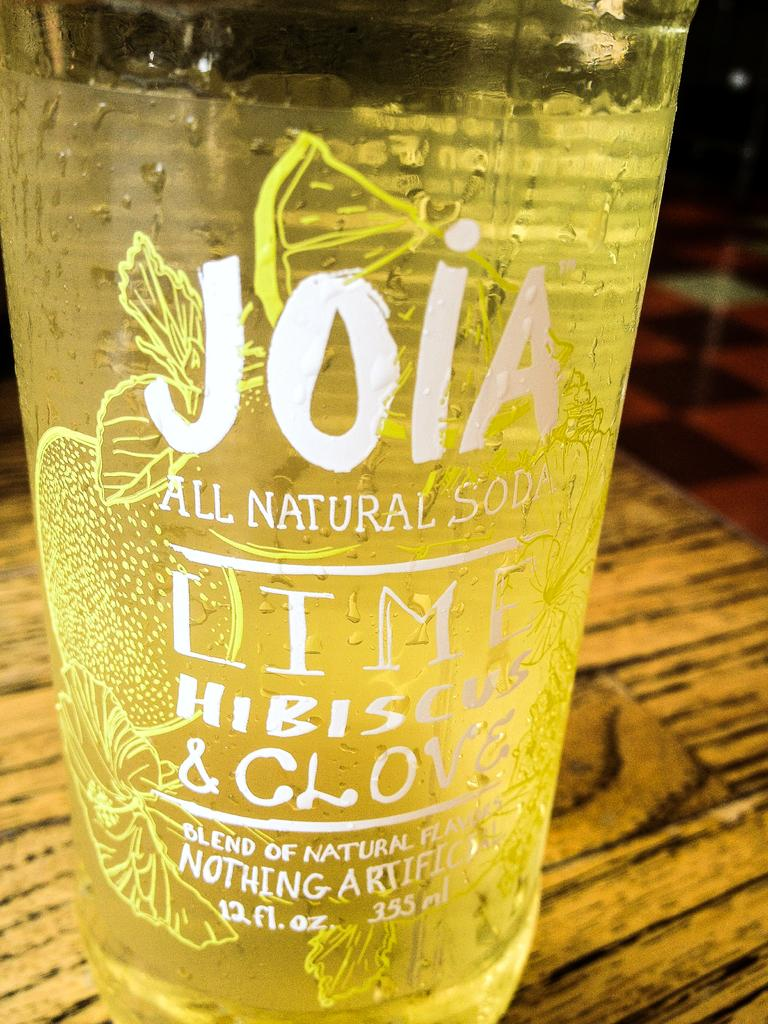<image>
Describe the image concisely. the yellow liquid in the bottle is hibiscus and clove flavored 